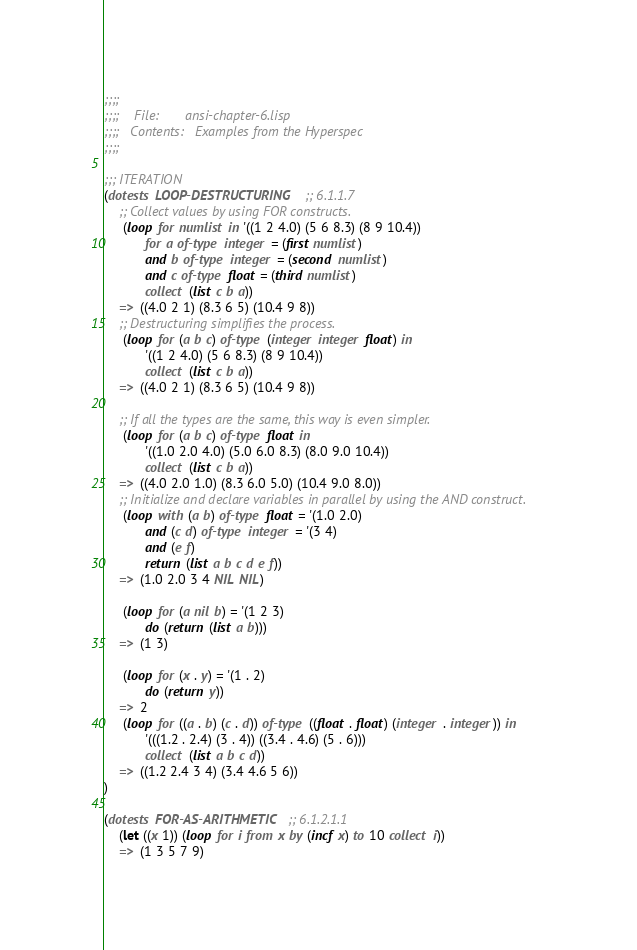Convert code to text. <code><loc_0><loc_0><loc_500><loc_500><_Lisp_>;;;;
;;;;	File:       ansi-chapter-6.lisp
;;;;   Contents:   Examples from the Hyperspec
;;;;

;;; ITERATION
(dotests LOOP-DESTRUCTURING  ;; 6.1.1.7
	;; Collect values by using FOR constructs.
	 (loop for numlist in '((1 2 4.0) (5 6 8.3) (8 9 10.4))
	       for a of-type integer = (first numlist)
	       and b of-type integer = (second numlist)
	       and c of-type float = (third numlist)
	       collect (list c b a))
	=>  ((4.0 2 1) (8.3 6 5) (10.4 9 8))
	;; Destructuring simplifies the process.
	 (loop for (a b c) of-type (integer integer float) in
	       '((1 2 4.0) (5 6 8.3) (8 9 10.4))
	       collect (list c b a))
	=>  ((4.0 2 1) (8.3 6 5) (10.4 9 8))
	 
	;; If all the types are the same, this way is even simpler.
	 (loop for (a b c) of-type float in
	       '((1.0 2.0 4.0) (5.0 6.0 8.3) (8.0 9.0 10.4))
	       collect (list c b a))
	=>  ((4.0 2.0 1.0) (8.3 6.0 5.0) (10.4 9.0 8.0))
	;; Initialize and declare variables in parallel by using the AND construct.
	 (loop with (a b) of-type float = '(1.0 2.0)
	       and (c d) of-type integer = '(3 4)
	       and (e f)
	       return (list a b c d e f))
	=>  (1.0 2.0 3 4 NIL NIL)
		
	 (loop for (a nil b) = '(1 2 3)
	       do (return (list a b)))
	=>  (1 3)
	
	 (loop for (x . y) = '(1 . 2)
	       do (return y))
	=>  2
	 (loop for ((a . b) (c . d)) of-type ((float . float) (integer . integer)) in
	       '(((1.2 . 2.4) (3 . 4)) ((3.4 . 4.6) (5 . 6)))
	       collect (list a b c d))
	=>  ((1.2 2.4 3 4) (3.4 4.6 5 6))
)

(dotests FOR-AS-ARITHMETIC  ;; 6.1.2.1.1
	(let ((x 1)) (loop for i from x by (incf x) to 10 collect i))
	=>  (1 3 5 7 9)</code> 